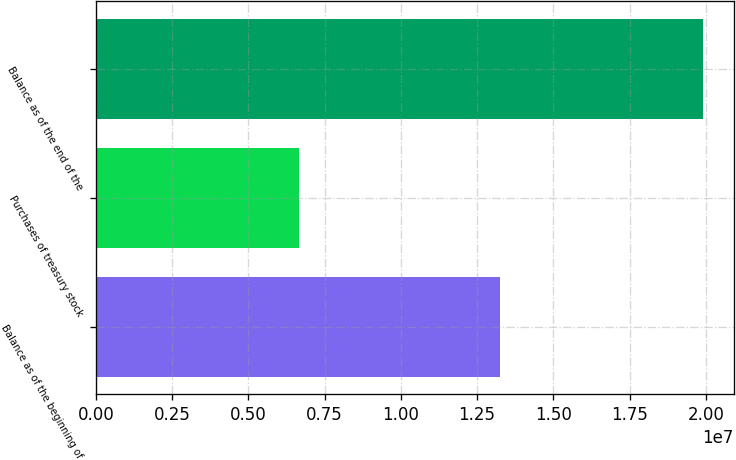Convert chart. <chart><loc_0><loc_0><loc_500><loc_500><bar_chart><fcel>Balance as of the beginning of<fcel>Purchases of treasury stock<fcel>Balance as of the end of the<nl><fcel>1.32666e+07<fcel>6.64986e+06<fcel>1.99165e+07<nl></chart> 